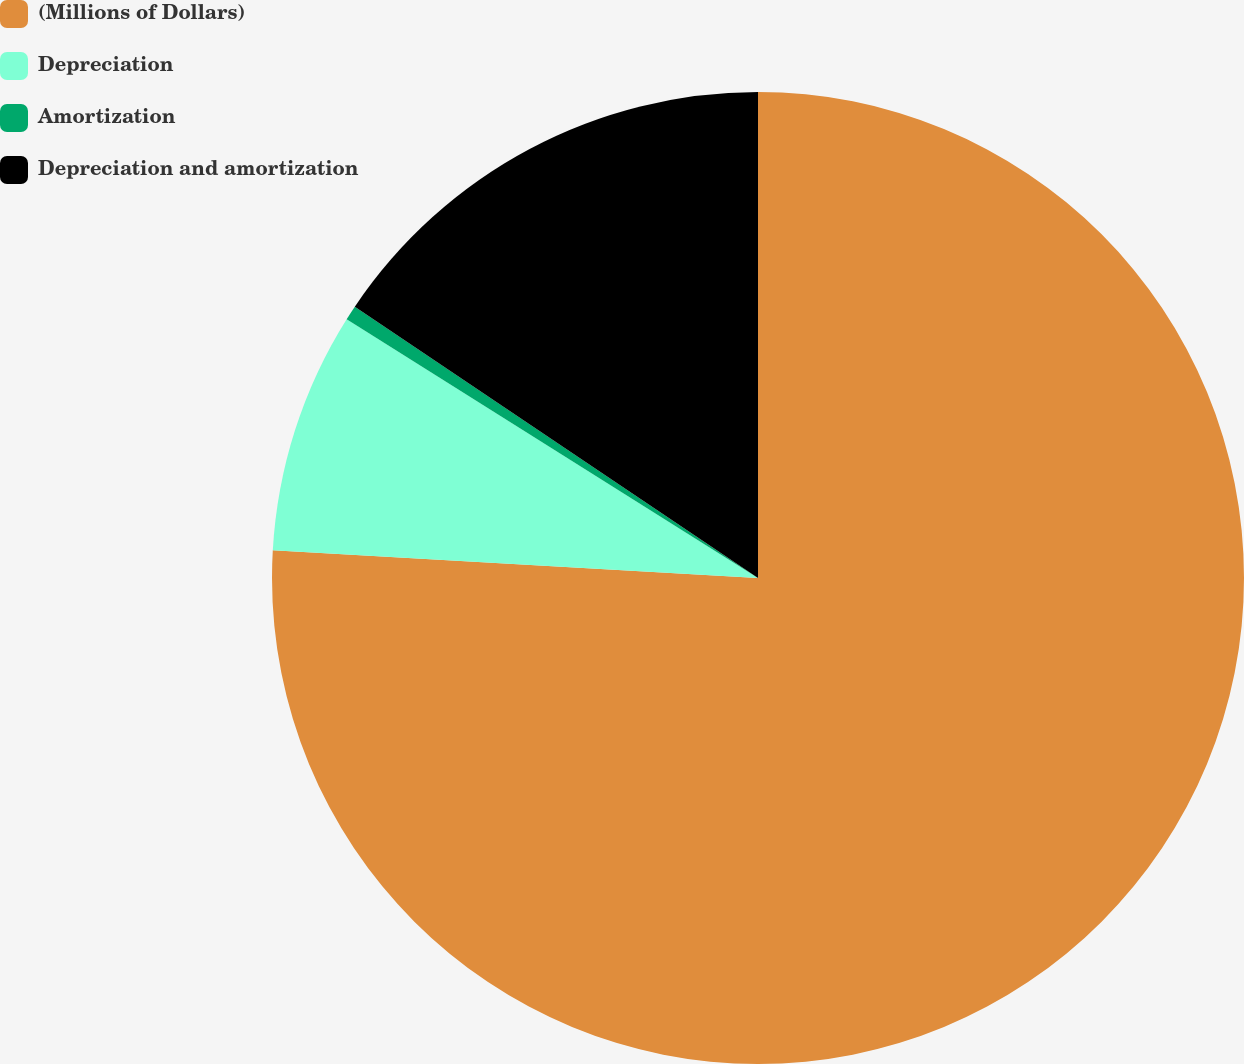Convert chart to OTSL. <chart><loc_0><loc_0><loc_500><loc_500><pie_chart><fcel>(Millions of Dollars)<fcel>Depreciation<fcel>Amortization<fcel>Depreciation and amortization<nl><fcel>75.9%<fcel>8.03%<fcel>0.49%<fcel>15.57%<nl></chart> 